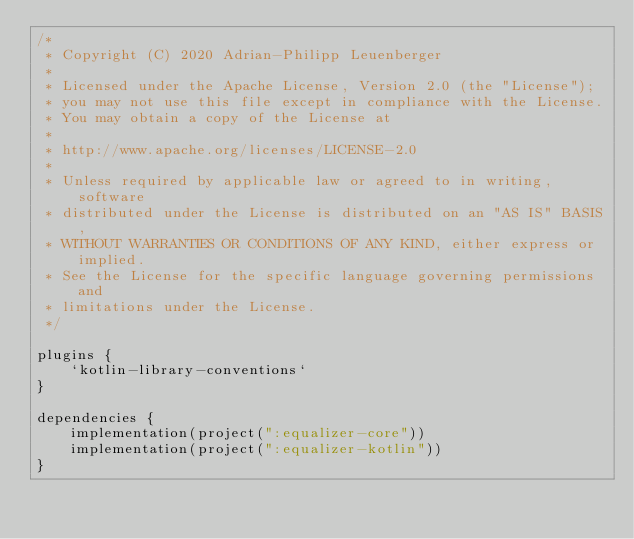Convert code to text. <code><loc_0><loc_0><loc_500><loc_500><_Kotlin_>/*
 * Copyright (C) 2020 Adrian-Philipp Leuenberger
 *
 * Licensed under the Apache License, Version 2.0 (the "License");
 * you may not use this file except in compliance with the License.
 * You may obtain a copy of the License at
 *
 * http://www.apache.org/licenses/LICENSE-2.0
 *
 * Unless required by applicable law or agreed to in writing, software
 * distributed under the License is distributed on an "AS IS" BASIS,
 * WITHOUT WARRANTIES OR CONDITIONS OF ANY KIND, either express or implied.
 * See the License for the specific language governing permissions and
 * limitations under the License.
 */

plugins {
    `kotlin-library-conventions`
}

dependencies {
    implementation(project(":equalizer-core"))
    implementation(project(":equalizer-kotlin"))
}</code> 